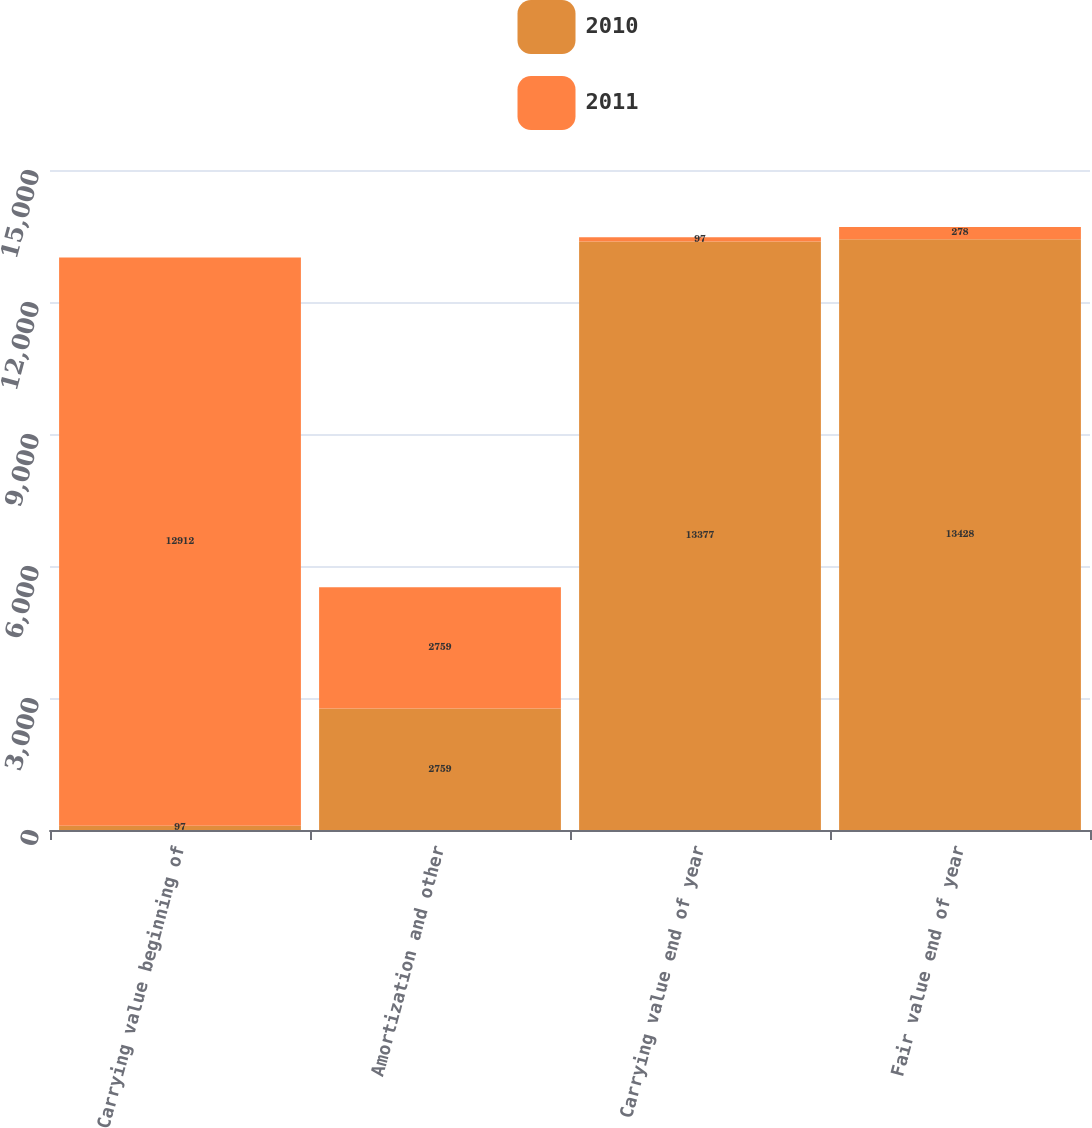Convert chart to OTSL. <chart><loc_0><loc_0><loc_500><loc_500><stacked_bar_chart><ecel><fcel>Carrying value beginning of<fcel>Amortization and other<fcel>Carrying value end of year<fcel>Fair value end of year<nl><fcel>2010<fcel>97<fcel>2759<fcel>13377<fcel>13428<nl><fcel>2011<fcel>12912<fcel>2759<fcel>97<fcel>278<nl></chart> 